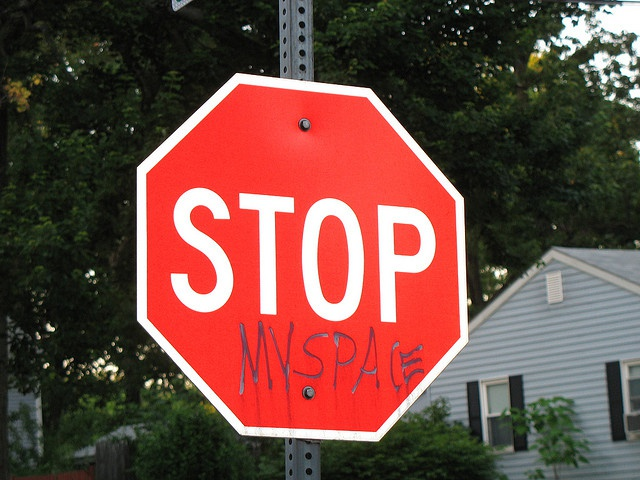Describe the objects in this image and their specific colors. I can see a stop sign in black, red, and white tones in this image. 